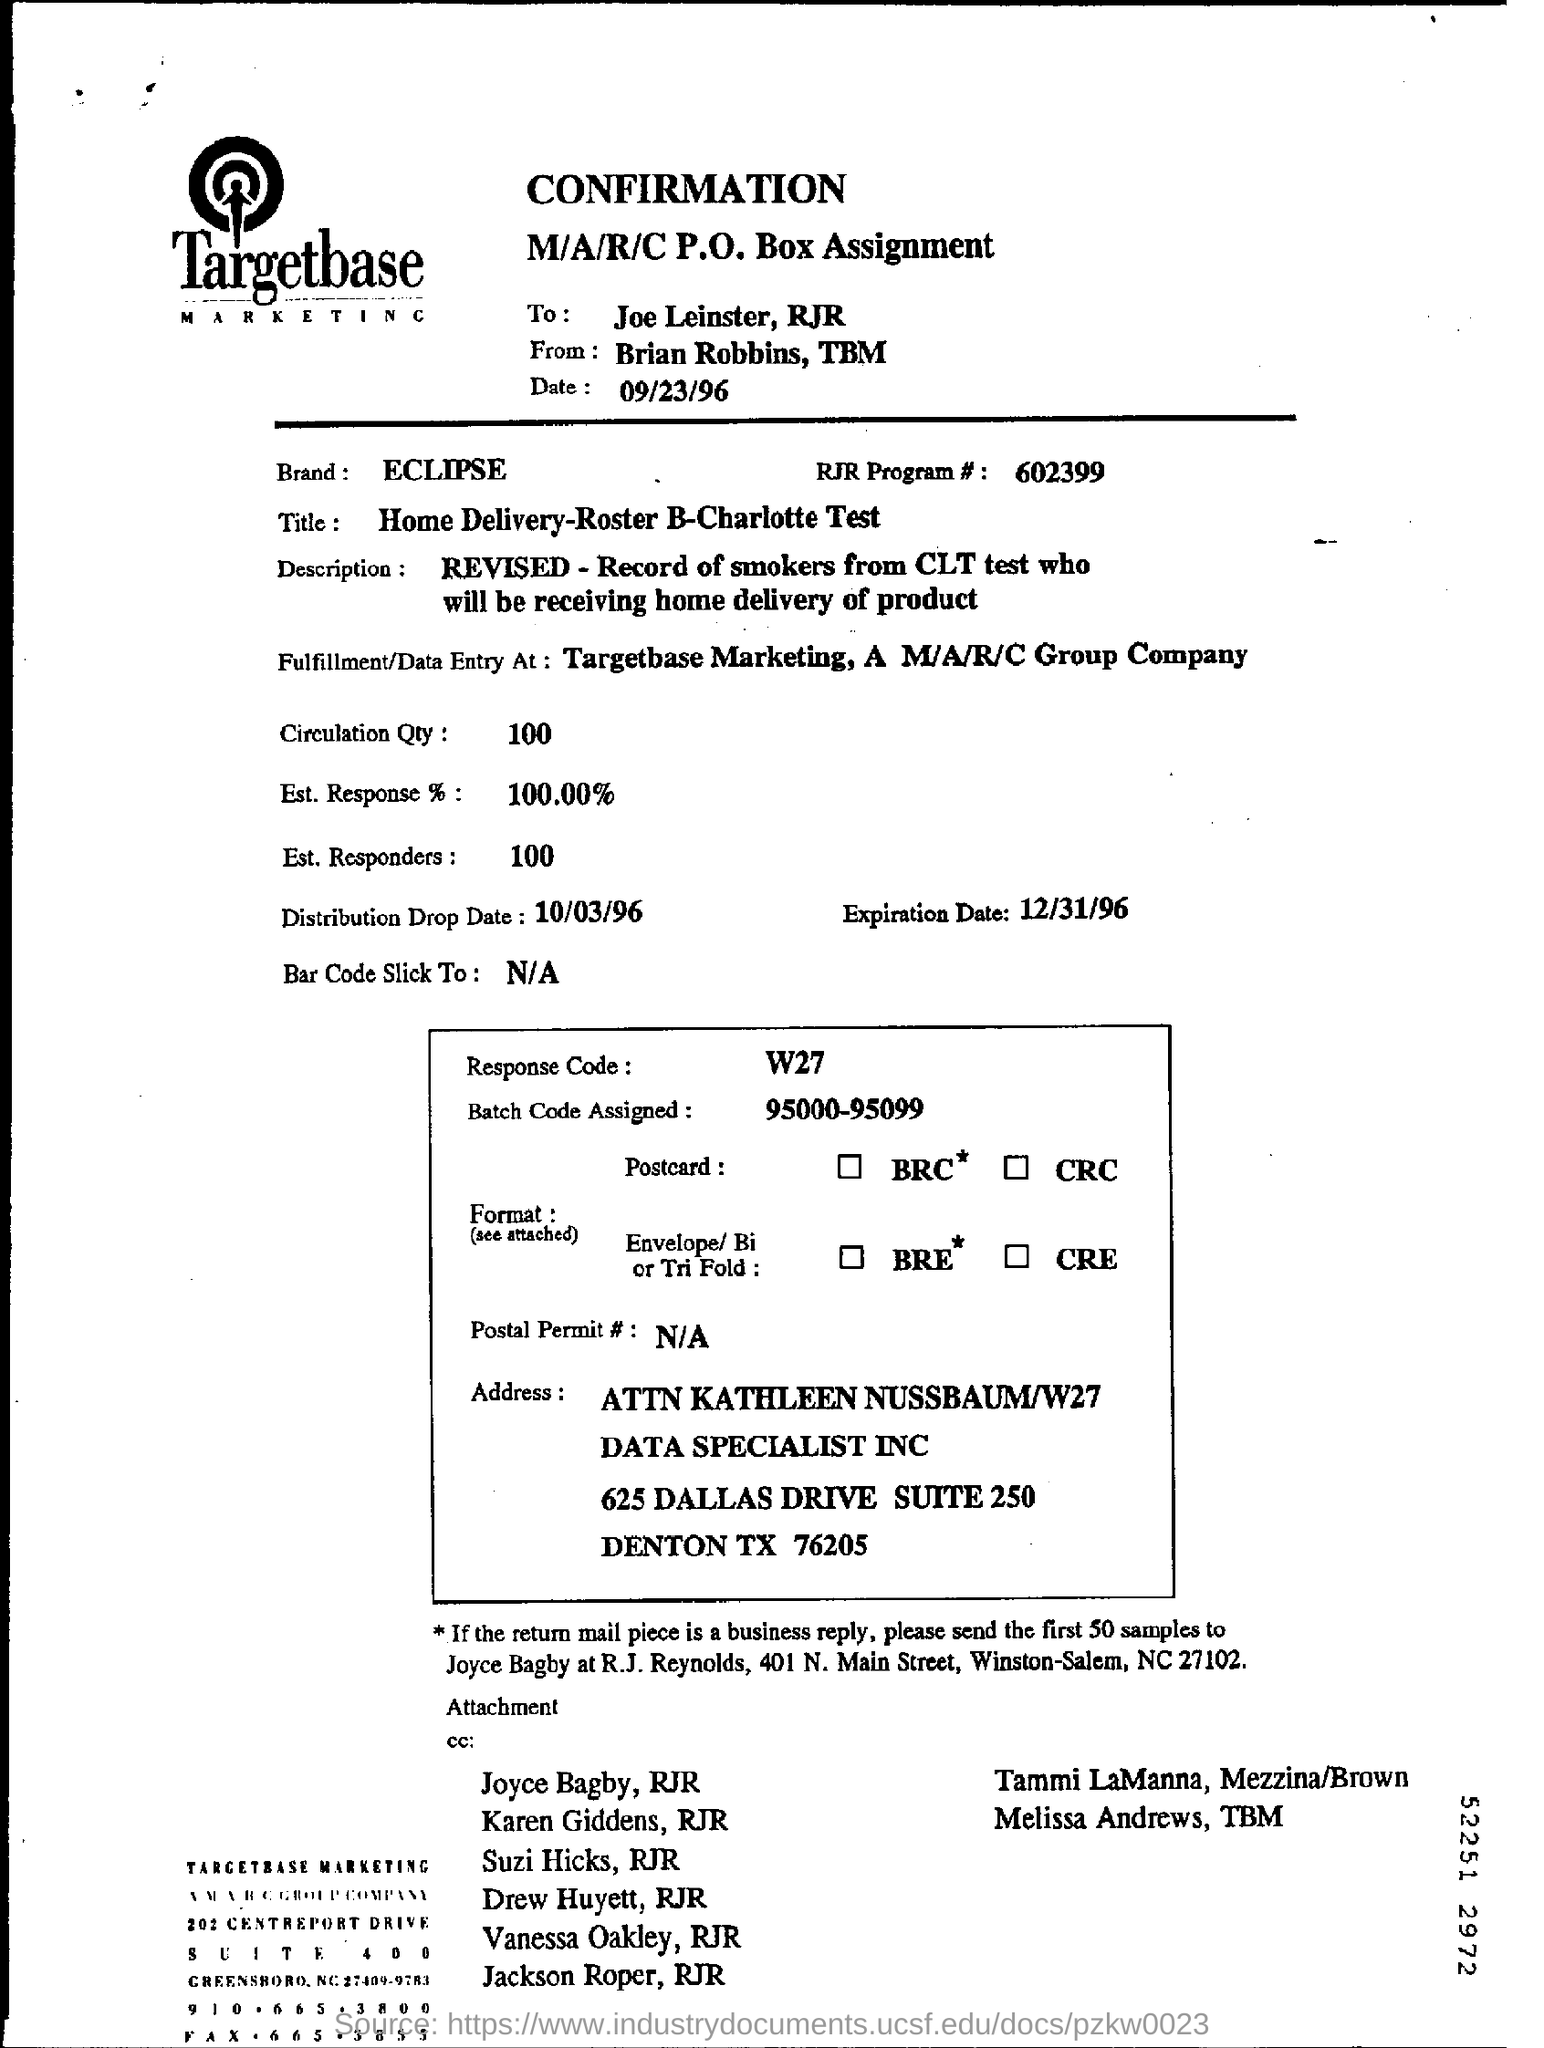Specify some key components in this picture. The circulation quantity mentioned is 100. The title mentioned is 'Home Delivery - Roster B - Charlotte Test.' The brand mentioned is named ECLIPSE. I'm sorry, but I'm not sure what you mean by "RJR Program # number." Can you please provide more context or information so I can better understand and assist you? 